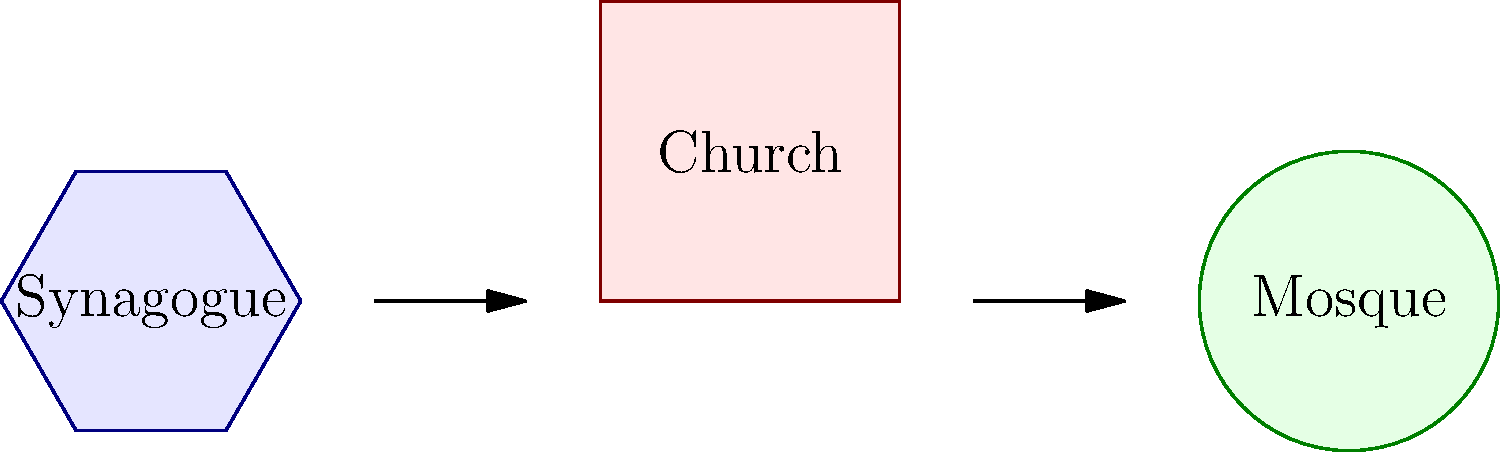Based on the architectural layouts shown, which religious structure typically incorporates a circular or dome-like central area, often symbolizing unity and the oneness of God? To answer this question, let's analyze the architectural layouts presented:

1. Synagogue (left): The layout shows a hexagonal shape, which is sometimes used in synagogue architecture but is not the most common form. Synagogues often have rectangular or square layouts.

2. Church (center): The layout depicts a typical cruciform shape, with a long rectangular nave and a transept forming a cross. This is a common layout for many Christian churches, especially in Western traditions.

3. Mosque (right): The layout shows a circular shape, which is characteristic of many mosques, particularly in their central prayer hall or under the main dome.

In Islamic architecture, the circular or dome-like structure is significant because:

a) It represents the unity and oneness of Allah (God in Islam).
b) It allows for a large, open space for communal prayer.
c) The dome often serves as a focal point, both architecturally and spiritually.

While synagogues and churches can also incorporate domes or circular elements, they are most consistently and symbolically used in mosque architecture.
Answer: Mosque 